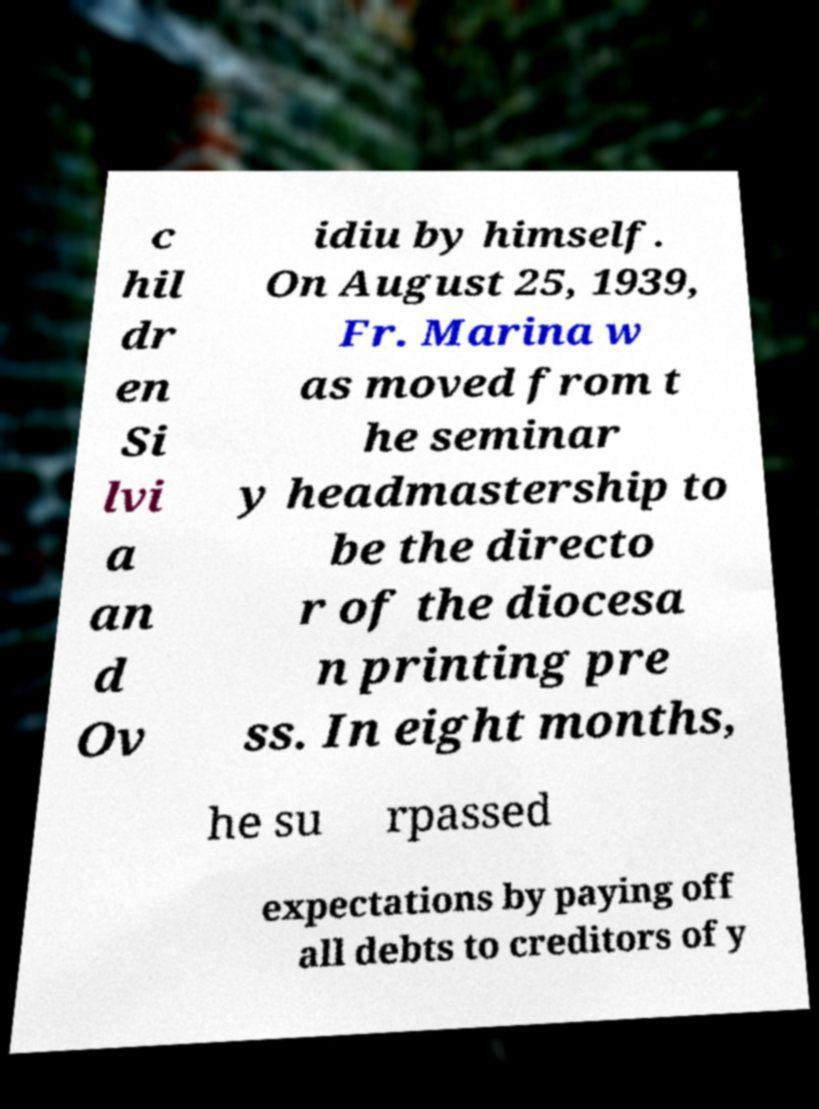There's text embedded in this image that I need extracted. Can you transcribe it verbatim? c hil dr en Si lvi a an d Ov idiu by himself. On August 25, 1939, Fr. Marina w as moved from t he seminar y headmastership to be the directo r of the diocesa n printing pre ss. In eight months, he su rpassed expectations by paying off all debts to creditors of y 